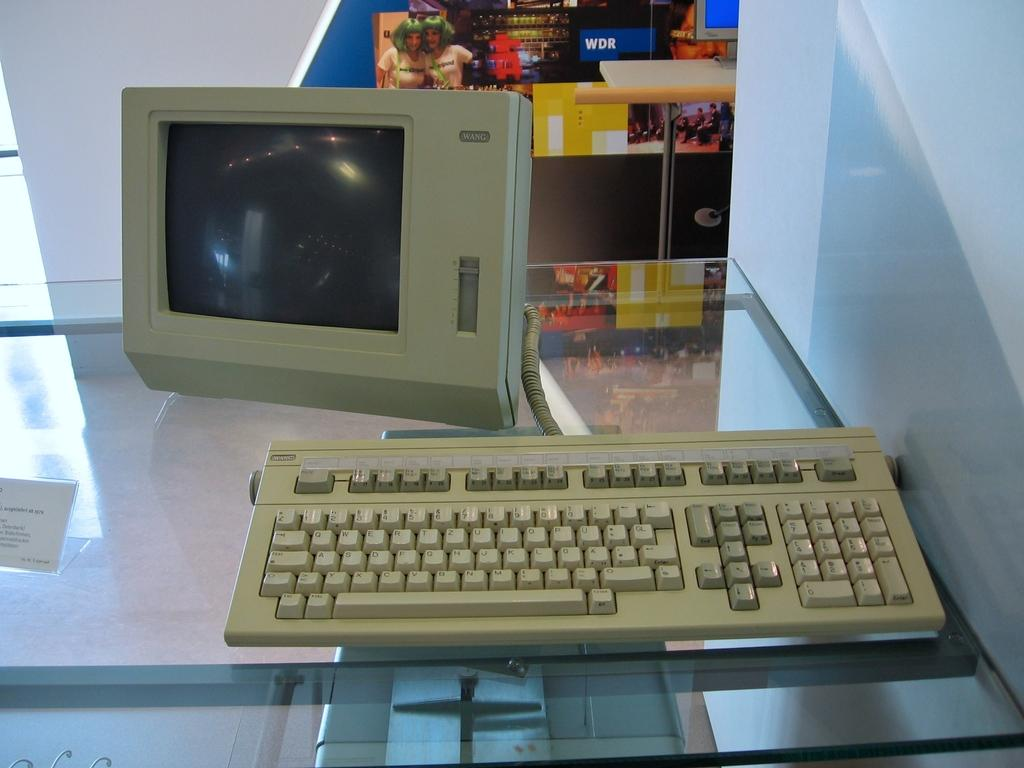What electronic device is visible in the image? There is a keyboard in the image. What is the keyboard connected to? There is a monitor screen in the image that the keyboard is connected to. Where are the keyboard and monitor screen located? They are on a glass table. What can be seen in the background of the image? There is a poster in the background of the image. How many jars of honey are on the glass table in the image? There are no jars of honey present in the image; it features a keyboard, monitor screen, and a poster in the background. What type of riddle can be solved using the keyboard and monitor screen in the image? There is no riddle present in the image, as it is a setup for using a computer. 